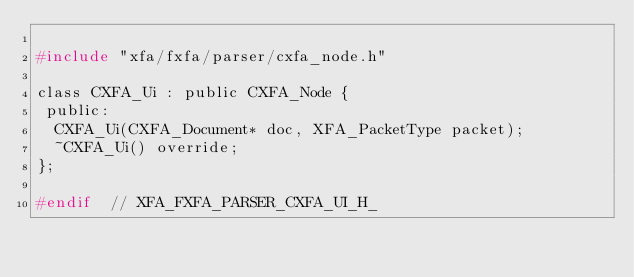Convert code to text. <code><loc_0><loc_0><loc_500><loc_500><_C_>
#include "xfa/fxfa/parser/cxfa_node.h"

class CXFA_Ui : public CXFA_Node {
 public:
  CXFA_Ui(CXFA_Document* doc, XFA_PacketType packet);
  ~CXFA_Ui() override;
};

#endif  // XFA_FXFA_PARSER_CXFA_UI_H_
</code> 